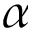Convert formula to latex. <formula><loc_0><loc_0><loc_500><loc_500>\alpha</formula> 